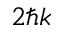<formula> <loc_0><loc_0><loc_500><loc_500>2 \hbar { k }</formula> 